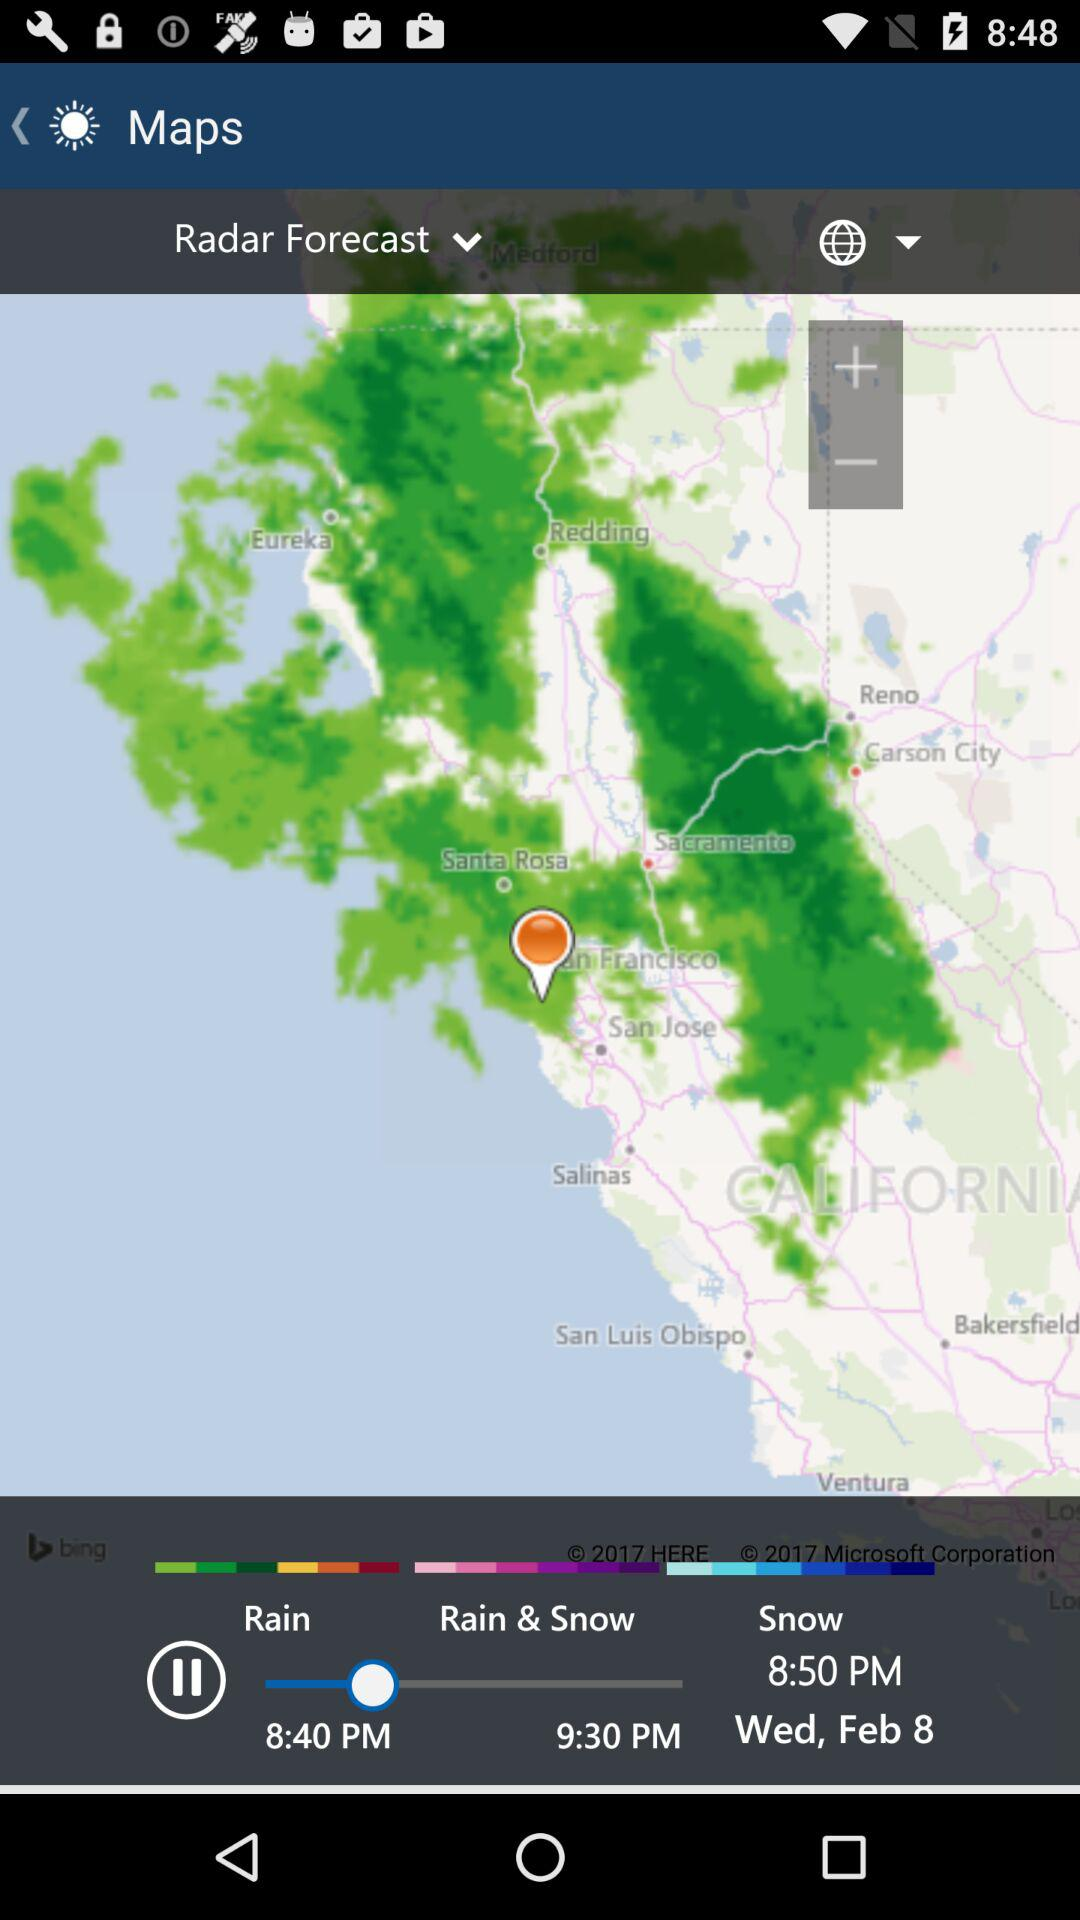Which date's weather forecast is shown? The date is Wednesday, February 8. 